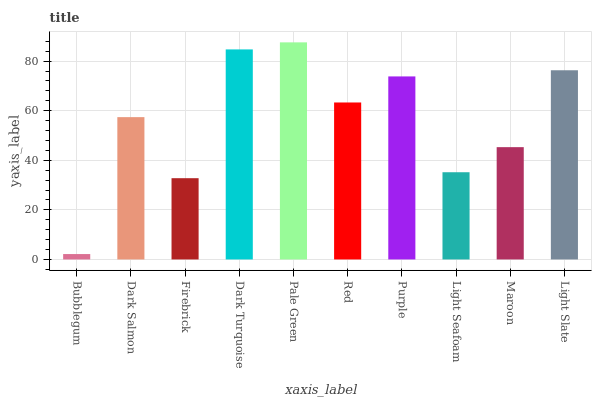Is Dark Salmon the minimum?
Answer yes or no. No. Is Dark Salmon the maximum?
Answer yes or no. No. Is Dark Salmon greater than Bubblegum?
Answer yes or no. Yes. Is Bubblegum less than Dark Salmon?
Answer yes or no. Yes. Is Bubblegum greater than Dark Salmon?
Answer yes or no. No. Is Dark Salmon less than Bubblegum?
Answer yes or no. No. Is Red the high median?
Answer yes or no. Yes. Is Dark Salmon the low median?
Answer yes or no. Yes. Is Purple the high median?
Answer yes or no. No. Is Dark Turquoise the low median?
Answer yes or no. No. 